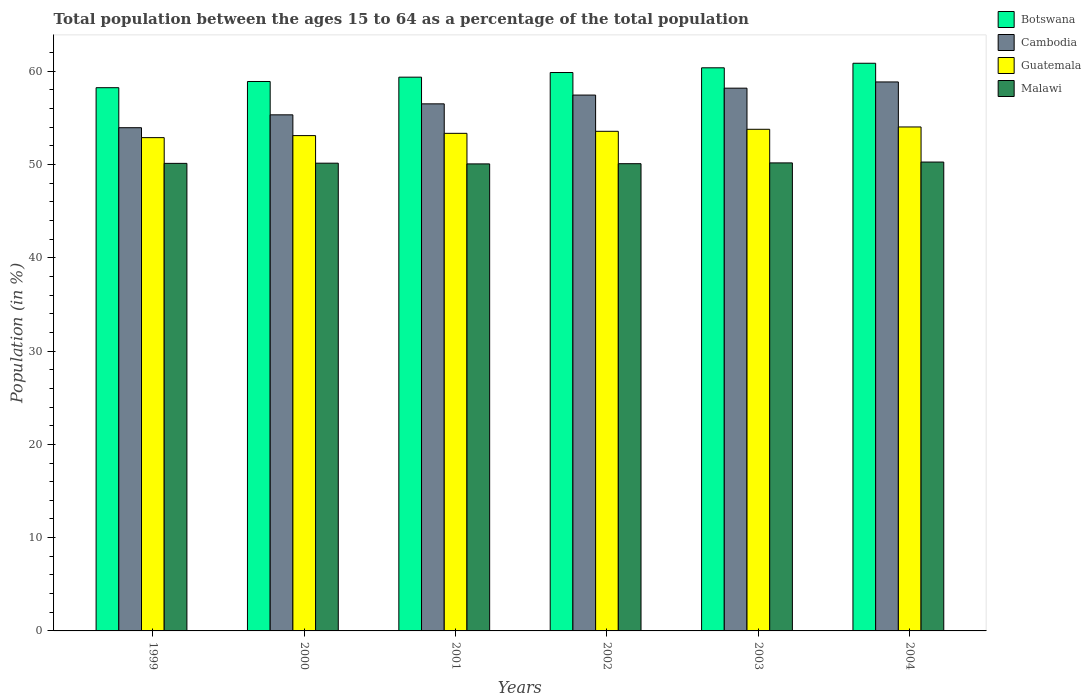How many different coloured bars are there?
Your answer should be compact. 4. How many groups of bars are there?
Your answer should be compact. 6. Are the number of bars on each tick of the X-axis equal?
Your answer should be very brief. Yes. How many bars are there on the 3rd tick from the left?
Your response must be concise. 4. What is the label of the 5th group of bars from the left?
Offer a terse response. 2003. In how many cases, is the number of bars for a given year not equal to the number of legend labels?
Offer a terse response. 0. What is the percentage of the population ages 15 to 64 in Malawi in 2001?
Provide a short and direct response. 50.06. Across all years, what is the maximum percentage of the population ages 15 to 64 in Malawi?
Offer a terse response. 50.26. Across all years, what is the minimum percentage of the population ages 15 to 64 in Malawi?
Make the answer very short. 50.06. In which year was the percentage of the population ages 15 to 64 in Cambodia maximum?
Provide a succinct answer. 2004. In which year was the percentage of the population ages 15 to 64 in Cambodia minimum?
Offer a very short reply. 1999. What is the total percentage of the population ages 15 to 64 in Botswana in the graph?
Your answer should be compact. 357.57. What is the difference between the percentage of the population ages 15 to 64 in Malawi in 1999 and that in 2004?
Provide a succinct answer. -0.14. What is the difference between the percentage of the population ages 15 to 64 in Guatemala in 2001 and the percentage of the population ages 15 to 64 in Cambodia in 2002?
Offer a very short reply. -4.1. What is the average percentage of the population ages 15 to 64 in Cambodia per year?
Ensure brevity in your answer.  56.71. In the year 2002, what is the difference between the percentage of the population ages 15 to 64 in Malawi and percentage of the population ages 15 to 64 in Botswana?
Offer a terse response. -9.77. What is the ratio of the percentage of the population ages 15 to 64 in Guatemala in 1999 to that in 2003?
Ensure brevity in your answer.  0.98. Is the percentage of the population ages 15 to 64 in Botswana in 2000 less than that in 2001?
Ensure brevity in your answer.  Yes. What is the difference between the highest and the second highest percentage of the population ages 15 to 64 in Malawi?
Offer a very short reply. 0.09. What is the difference between the highest and the lowest percentage of the population ages 15 to 64 in Malawi?
Make the answer very short. 0.2. In how many years, is the percentage of the population ages 15 to 64 in Malawi greater than the average percentage of the population ages 15 to 64 in Malawi taken over all years?
Give a very brief answer. 3. What does the 1st bar from the left in 2003 represents?
Offer a very short reply. Botswana. What does the 3rd bar from the right in 2001 represents?
Make the answer very short. Cambodia. Are all the bars in the graph horizontal?
Your answer should be compact. No. What is the difference between two consecutive major ticks on the Y-axis?
Offer a terse response. 10. Does the graph contain any zero values?
Your answer should be compact. No. Does the graph contain grids?
Provide a short and direct response. No. Where does the legend appear in the graph?
Keep it short and to the point. Top right. What is the title of the graph?
Your answer should be very brief. Total population between the ages 15 to 64 as a percentage of the total population. What is the Population (in %) in Botswana in 1999?
Ensure brevity in your answer.  58.23. What is the Population (in %) in Cambodia in 1999?
Your answer should be very brief. 53.94. What is the Population (in %) in Guatemala in 1999?
Ensure brevity in your answer.  52.88. What is the Population (in %) in Malawi in 1999?
Your answer should be compact. 50.12. What is the Population (in %) in Botswana in 2000?
Keep it short and to the point. 58.9. What is the Population (in %) of Cambodia in 2000?
Make the answer very short. 55.32. What is the Population (in %) of Guatemala in 2000?
Offer a very short reply. 53.1. What is the Population (in %) in Malawi in 2000?
Your answer should be very brief. 50.14. What is the Population (in %) in Botswana in 2001?
Ensure brevity in your answer.  59.36. What is the Population (in %) of Cambodia in 2001?
Keep it short and to the point. 56.5. What is the Population (in %) in Guatemala in 2001?
Make the answer very short. 53.34. What is the Population (in %) in Malawi in 2001?
Keep it short and to the point. 50.06. What is the Population (in %) in Botswana in 2002?
Make the answer very short. 59.86. What is the Population (in %) in Cambodia in 2002?
Your answer should be compact. 57.44. What is the Population (in %) of Guatemala in 2002?
Provide a short and direct response. 53.56. What is the Population (in %) in Malawi in 2002?
Make the answer very short. 50.09. What is the Population (in %) of Botswana in 2003?
Ensure brevity in your answer.  60.37. What is the Population (in %) in Cambodia in 2003?
Your answer should be compact. 58.18. What is the Population (in %) in Guatemala in 2003?
Your response must be concise. 53.77. What is the Population (in %) in Malawi in 2003?
Provide a succinct answer. 50.17. What is the Population (in %) of Botswana in 2004?
Your response must be concise. 60.85. What is the Population (in %) in Cambodia in 2004?
Ensure brevity in your answer.  58.85. What is the Population (in %) of Guatemala in 2004?
Make the answer very short. 54.02. What is the Population (in %) of Malawi in 2004?
Your response must be concise. 50.26. Across all years, what is the maximum Population (in %) of Botswana?
Keep it short and to the point. 60.85. Across all years, what is the maximum Population (in %) in Cambodia?
Your response must be concise. 58.85. Across all years, what is the maximum Population (in %) of Guatemala?
Your response must be concise. 54.02. Across all years, what is the maximum Population (in %) of Malawi?
Your answer should be very brief. 50.26. Across all years, what is the minimum Population (in %) in Botswana?
Ensure brevity in your answer.  58.23. Across all years, what is the minimum Population (in %) in Cambodia?
Offer a very short reply. 53.94. Across all years, what is the minimum Population (in %) of Guatemala?
Your response must be concise. 52.88. Across all years, what is the minimum Population (in %) in Malawi?
Make the answer very short. 50.06. What is the total Population (in %) in Botswana in the graph?
Your answer should be very brief. 357.57. What is the total Population (in %) in Cambodia in the graph?
Your answer should be very brief. 340.24. What is the total Population (in %) of Guatemala in the graph?
Provide a short and direct response. 320.67. What is the total Population (in %) of Malawi in the graph?
Provide a succinct answer. 300.84. What is the difference between the Population (in %) of Botswana in 1999 and that in 2000?
Your response must be concise. -0.66. What is the difference between the Population (in %) in Cambodia in 1999 and that in 2000?
Make the answer very short. -1.38. What is the difference between the Population (in %) in Guatemala in 1999 and that in 2000?
Keep it short and to the point. -0.22. What is the difference between the Population (in %) of Malawi in 1999 and that in 2000?
Your answer should be very brief. -0.02. What is the difference between the Population (in %) of Botswana in 1999 and that in 2001?
Your answer should be very brief. -1.13. What is the difference between the Population (in %) in Cambodia in 1999 and that in 2001?
Your answer should be compact. -2.56. What is the difference between the Population (in %) in Guatemala in 1999 and that in 2001?
Your answer should be very brief. -0.46. What is the difference between the Population (in %) of Malawi in 1999 and that in 2001?
Keep it short and to the point. 0.06. What is the difference between the Population (in %) of Botswana in 1999 and that in 2002?
Your response must be concise. -1.63. What is the difference between the Population (in %) of Cambodia in 1999 and that in 2002?
Your response must be concise. -3.5. What is the difference between the Population (in %) in Guatemala in 1999 and that in 2002?
Give a very brief answer. -0.68. What is the difference between the Population (in %) in Malawi in 1999 and that in 2002?
Provide a succinct answer. 0.03. What is the difference between the Population (in %) of Botswana in 1999 and that in 2003?
Your response must be concise. -2.13. What is the difference between the Population (in %) of Cambodia in 1999 and that in 2003?
Give a very brief answer. -4.24. What is the difference between the Population (in %) in Guatemala in 1999 and that in 2003?
Make the answer very short. -0.89. What is the difference between the Population (in %) of Malawi in 1999 and that in 2003?
Your answer should be very brief. -0.05. What is the difference between the Population (in %) in Botswana in 1999 and that in 2004?
Provide a succinct answer. -2.62. What is the difference between the Population (in %) in Cambodia in 1999 and that in 2004?
Your answer should be very brief. -4.91. What is the difference between the Population (in %) in Guatemala in 1999 and that in 2004?
Provide a short and direct response. -1.14. What is the difference between the Population (in %) in Malawi in 1999 and that in 2004?
Ensure brevity in your answer.  -0.14. What is the difference between the Population (in %) in Botswana in 2000 and that in 2001?
Your answer should be compact. -0.46. What is the difference between the Population (in %) of Cambodia in 2000 and that in 2001?
Offer a very short reply. -1.18. What is the difference between the Population (in %) in Guatemala in 2000 and that in 2001?
Ensure brevity in your answer.  -0.24. What is the difference between the Population (in %) in Malawi in 2000 and that in 2001?
Your response must be concise. 0.08. What is the difference between the Population (in %) in Botswana in 2000 and that in 2002?
Offer a very short reply. -0.96. What is the difference between the Population (in %) of Cambodia in 2000 and that in 2002?
Provide a succinct answer. -2.12. What is the difference between the Population (in %) of Guatemala in 2000 and that in 2002?
Your answer should be compact. -0.46. What is the difference between the Population (in %) of Malawi in 2000 and that in 2002?
Keep it short and to the point. 0.06. What is the difference between the Population (in %) in Botswana in 2000 and that in 2003?
Your answer should be compact. -1.47. What is the difference between the Population (in %) in Cambodia in 2000 and that in 2003?
Offer a very short reply. -2.86. What is the difference between the Population (in %) in Guatemala in 2000 and that in 2003?
Your answer should be very brief. -0.68. What is the difference between the Population (in %) of Malawi in 2000 and that in 2003?
Provide a succinct answer. -0.03. What is the difference between the Population (in %) in Botswana in 2000 and that in 2004?
Keep it short and to the point. -1.95. What is the difference between the Population (in %) of Cambodia in 2000 and that in 2004?
Ensure brevity in your answer.  -3.53. What is the difference between the Population (in %) in Guatemala in 2000 and that in 2004?
Your answer should be very brief. -0.93. What is the difference between the Population (in %) of Malawi in 2000 and that in 2004?
Offer a very short reply. -0.12. What is the difference between the Population (in %) of Botswana in 2001 and that in 2002?
Provide a short and direct response. -0.5. What is the difference between the Population (in %) in Cambodia in 2001 and that in 2002?
Your answer should be very brief. -0.94. What is the difference between the Population (in %) of Guatemala in 2001 and that in 2002?
Your answer should be very brief. -0.22. What is the difference between the Population (in %) of Malawi in 2001 and that in 2002?
Your answer should be very brief. -0.02. What is the difference between the Population (in %) of Botswana in 2001 and that in 2003?
Keep it short and to the point. -1. What is the difference between the Population (in %) in Cambodia in 2001 and that in 2003?
Keep it short and to the point. -1.68. What is the difference between the Population (in %) of Guatemala in 2001 and that in 2003?
Keep it short and to the point. -0.43. What is the difference between the Population (in %) of Malawi in 2001 and that in 2003?
Your answer should be compact. -0.11. What is the difference between the Population (in %) in Botswana in 2001 and that in 2004?
Give a very brief answer. -1.49. What is the difference between the Population (in %) in Cambodia in 2001 and that in 2004?
Keep it short and to the point. -2.35. What is the difference between the Population (in %) of Guatemala in 2001 and that in 2004?
Provide a succinct answer. -0.68. What is the difference between the Population (in %) in Malawi in 2001 and that in 2004?
Make the answer very short. -0.2. What is the difference between the Population (in %) in Botswana in 2002 and that in 2003?
Provide a short and direct response. -0.51. What is the difference between the Population (in %) of Cambodia in 2002 and that in 2003?
Provide a succinct answer. -0.74. What is the difference between the Population (in %) in Guatemala in 2002 and that in 2003?
Provide a short and direct response. -0.22. What is the difference between the Population (in %) of Malawi in 2002 and that in 2003?
Make the answer very short. -0.08. What is the difference between the Population (in %) in Botswana in 2002 and that in 2004?
Make the answer very short. -0.99. What is the difference between the Population (in %) of Cambodia in 2002 and that in 2004?
Provide a short and direct response. -1.41. What is the difference between the Population (in %) of Guatemala in 2002 and that in 2004?
Make the answer very short. -0.47. What is the difference between the Population (in %) in Malawi in 2002 and that in 2004?
Give a very brief answer. -0.18. What is the difference between the Population (in %) of Botswana in 2003 and that in 2004?
Provide a short and direct response. -0.49. What is the difference between the Population (in %) in Cambodia in 2003 and that in 2004?
Keep it short and to the point. -0.67. What is the difference between the Population (in %) in Guatemala in 2003 and that in 2004?
Ensure brevity in your answer.  -0.25. What is the difference between the Population (in %) of Malawi in 2003 and that in 2004?
Ensure brevity in your answer.  -0.09. What is the difference between the Population (in %) in Botswana in 1999 and the Population (in %) in Cambodia in 2000?
Make the answer very short. 2.91. What is the difference between the Population (in %) in Botswana in 1999 and the Population (in %) in Guatemala in 2000?
Give a very brief answer. 5.14. What is the difference between the Population (in %) of Botswana in 1999 and the Population (in %) of Malawi in 2000?
Offer a terse response. 8.09. What is the difference between the Population (in %) of Cambodia in 1999 and the Population (in %) of Guatemala in 2000?
Give a very brief answer. 0.85. What is the difference between the Population (in %) of Cambodia in 1999 and the Population (in %) of Malawi in 2000?
Your answer should be compact. 3.8. What is the difference between the Population (in %) in Guatemala in 1999 and the Population (in %) in Malawi in 2000?
Your answer should be very brief. 2.74. What is the difference between the Population (in %) in Botswana in 1999 and the Population (in %) in Cambodia in 2001?
Offer a terse response. 1.73. What is the difference between the Population (in %) in Botswana in 1999 and the Population (in %) in Guatemala in 2001?
Offer a terse response. 4.89. What is the difference between the Population (in %) of Botswana in 1999 and the Population (in %) of Malawi in 2001?
Your answer should be compact. 8.17. What is the difference between the Population (in %) in Cambodia in 1999 and the Population (in %) in Guatemala in 2001?
Provide a succinct answer. 0.6. What is the difference between the Population (in %) of Cambodia in 1999 and the Population (in %) of Malawi in 2001?
Your answer should be compact. 3.88. What is the difference between the Population (in %) of Guatemala in 1999 and the Population (in %) of Malawi in 2001?
Make the answer very short. 2.82. What is the difference between the Population (in %) of Botswana in 1999 and the Population (in %) of Cambodia in 2002?
Offer a very short reply. 0.79. What is the difference between the Population (in %) in Botswana in 1999 and the Population (in %) in Guatemala in 2002?
Provide a succinct answer. 4.67. What is the difference between the Population (in %) of Botswana in 1999 and the Population (in %) of Malawi in 2002?
Give a very brief answer. 8.15. What is the difference between the Population (in %) of Cambodia in 1999 and the Population (in %) of Guatemala in 2002?
Your answer should be very brief. 0.39. What is the difference between the Population (in %) of Cambodia in 1999 and the Population (in %) of Malawi in 2002?
Provide a short and direct response. 3.86. What is the difference between the Population (in %) in Guatemala in 1999 and the Population (in %) in Malawi in 2002?
Give a very brief answer. 2.79. What is the difference between the Population (in %) of Botswana in 1999 and the Population (in %) of Cambodia in 2003?
Ensure brevity in your answer.  0.05. What is the difference between the Population (in %) of Botswana in 1999 and the Population (in %) of Guatemala in 2003?
Offer a very short reply. 4.46. What is the difference between the Population (in %) of Botswana in 1999 and the Population (in %) of Malawi in 2003?
Provide a short and direct response. 8.06. What is the difference between the Population (in %) of Cambodia in 1999 and the Population (in %) of Guatemala in 2003?
Your answer should be compact. 0.17. What is the difference between the Population (in %) of Cambodia in 1999 and the Population (in %) of Malawi in 2003?
Ensure brevity in your answer.  3.77. What is the difference between the Population (in %) in Guatemala in 1999 and the Population (in %) in Malawi in 2003?
Offer a terse response. 2.71. What is the difference between the Population (in %) in Botswana in 1999 and the Population (in %) in Cambodia in 2004?
Your answer should be compact. -0.62. What is the difference between the Population (in %) in Botswana in 1999 and the Population (in %) in Guatemala in 2004?
Your response must be concise. 4.21. What is the difference between the Population (in %) of Botswana in 1999 and the Population (in %) of Malawi in 2004?
Give a very brief answer. 7.97. What is the difference between the Population (in %) in Cambodia in 1999 and the Population (in %) in Guatemala in 2004?
Offer a very short reply. -0.08. What is the difference between the Population (in %) of Cambodia in 1999 and the Population (in %) of Malawi in 2004?
Offer a very short reply. 3.68. What is the difference between the Population (in %) in Guatemala in 1999 and the Population (in %) in Malawi in 2004?
Offer a terse response. 2.62. What is the difference between the Population (in %) of Botswana in 2000 and the Population (in %) of Cambodia in 2001?
Offer a terse response. 2.4. What is the difference between the Population (in %) in Botswana in 2000 and the Population (in %) in Guatemala in 2001?
Keep it short and to the point. 5.56. What is the difference between the Population (in %) of Botswana in 2000 and the Population (in %) of Malawi in 2001?
Provide a succinct answer. 8.83. What is the difference between the Population (in %) in Cambodia in 2000 and the Population (in %) in Guatemala in 2001?
Your answer should be very brief. 1.98. What is the difference between the Population (in %) in Cambodia in 2000 and the Population (in %) in Malawi in 2001?
Your response must be concise. 5.26. What is the difference between the Population (in %) in Guatemala in 2000 and the Population (in %) in Malawi in 2001?
Give a very brief answer. 3.03. What is the difference between the Population (in %) of Botswana in 2000 and the Population (in %) of Cambodia in 2002?
Give a very brief answer. 1.46. What is the difference between the Population (in %) of Botswana in 2000 and the Population (in %) of Guatemala in 2002?
Make the answer very short. 5.34. What is the difference between the Population (in %) of Botswana in 2000 and the Population (in %) of Malawi in 2002?
Offer a terse response. 8.81. What is the difference between the Population (in %) of Cambodia in 2000 and the Population (in %) of Guatemala in 2002?
Offer a terse response. 1.76. What is the difference between the Population (in %) of Cambodia in 2000 and the Population (in %) of Malawi in 2002?
Offer a terse response. 5.24. What is the difference between the Population (in %) of Guatemala in 2000 and the Population (in %) of Malawi in 2002?
Provide a short and direct response. 3.01. What is the difference between the Population (in %) in Botswana in 2000 and the Population (in %) in Cambodia in 2003?
Your answer should be compact. 0.72. What is the difference between the Population (in %) in Botswana in 2000 and the Population (in %) in Guatemala in 2003?
Your response must be concise. 5.12. What is the difference between the Population (in %) in Botswana in 2000 and the Population (in %) in Malawi in 2003?
Keep it short and to the point. 8.73. What is the difference between the Population (in %) of Cambodia in 2000 and the Population (in %) of Guatemala in 2003?
Keep it short and to the point. 1.55. What is the difference between the Population (in %) of Cambodia in 2000 and the Population (in %) of Malawi in 2003?
Provide a short and direct response. 5.15. What is the difference between the Population (in %) in Guatemala in 2000 and the Population (in %) in Malawi in 2003?
Give a very brief answer. 2.93. What is the difference between the Population (in %) in Botswana in 2000 and the Population (in %) in Cambodia in 2004?
Your answer should be very brief. 0.05. What is the difference between the Population (in %) of Botswana in 2000 and the Population (in %) of Guatemala in 2004?
Provide a succinct answer. 4.87. What is the difference between the Population (in %) in Botswana in 2000 and the Population (in %) in Malawi in 2004?
Ensure brevity in your answer.  8.64. What is the difference between the Population (in %) in Cambodia in 2000 and the Population (in %) in Guatemala in 2004?
Ensure brevity in your answer.  1.3. What is the difference between the Population (in %) of Cambodia in 2000 and the Population (in %) of Malawi in 2004?
Give a very brief answer. 5.06. What is the difference between the Population (in %) in Guatemala in 2000 and the Population (in %) in Malawi in 2004?
Your response must be concise. 2.84. What is the difference between the Population (in %) in Botswana in 2001 and the Population (in %) in Cambodia in 2002?
Keep it short and to the point. 1.92. What is the difference between the Population (in %) in Botswana in 2001 and the Population (in %) in Guatemala in 2002?
Your answer should be very brief. 5.8. What is the difference between the Population (in %) in Botswana in 2001 and the Population (in %) in Malawi in 2002?
Give a very brief answer. 9.28. What is the difference between the Population (in %) in Cambodia in 2001 and the Population (in %) in Guatemala in 2002?
Your answer should be compact. 2.94. What is the difference between the Population (in %) in Cambodia in 2001 and the Population (in %) in Malawi in 2002?
Give a very brief answer. 6.42. What is the difference between the Population (in %) of Guatemala in 2001 and the Population (in %) of Malawi in 2002?
Make the answer very short. 3.25. What is the difference between the Population (in %) in Botswana in 2001 and the Population (in %) in Cambodia in 2003?
Your response must be concise. 1.18. What is the difference between the Population (in %) in Botswana in 2001 and the Population (in %) in Guatemala in 2003?
Provide a succinct answer. 5.59. What is the difference between the Population (in %) of Botswana in 2001 and the Population (in %) of Malawi in 2003?
Your answer should be compact. 9.19. What is the difference between the Population (in %) of Cambodia in 2001 and the Population (in %) of Guatemala in 2003?
Keep it short and to the point. 2.73. What is the difference between the Population (in %) in Cambodia in 2001 and the Population (in %) in Malawi in 2003?
Keep it short and to the point. 6.33. What is the difference between the Population (in %) of Guatemala in 2001 and the Population (in %) of Malawi in 2003?
Provide a short and direct response. 3.17. What is the difference between the Population (in %) of Botswana in 2001 and the Population (in %) of Cambodia in 2004?
Give a very brief answer. 0.51. What is the difference between the Population (in %) in Botswana in 2001 and the Population (in %) in Guatemala in 2004?
Your answer should be very brief. 5.34. What is the difference between the Population (in %) in Botswana in 2001 and the Population (in %) in Malawi in 2004?
Your response must be concise. 9.1. What is the difference between the Population (in %) of Cambodia in 2001 and the Population (in %) of Guatemala in 2004?
Your answer should be compact. 2.48. What is the difference between the Population (in %) in Cambodia in 2001 and the Population (in %) in Malawi in 2004?
Your answer should be compact. 6.24. What is the difference between the Population (in %) in Guatemala in 2001 and the Population (in %) in Malawi in 2004?
Your answer should be very brief. 3.08. What is the difference between the Population (in %) of Botswana in 2002 and the Population (in %) of Cambodia in 2003?
Provide a succinct answer. 1.68. What is the difference between the Population (in %) of Botswana in 2002 and the Population (in %) of Guatemala in 2003?
Your answer should be compact. 6.08. What is the difference between the Population (in %) in Botswana in 2002 and the Population (in %) in Malawi in 2003?
Provide a succinct answer. 9.69. What is the difference between the Population (in %) of Cambodia in 2002 and the Population (in %) of Guatemala in 2003?
Your response must be concise. 3.67. What is the difference between the Population (in %) in Cambodia in 2002 and the Population (in %) in Malawi in 2003?
Your answer should be very brief. 7.27. What is the difference between the Population (in %) of Guatemala in 2002 and the Population (in %) of Malawi in 2003?
Your response must be concise. 3.39. What is the difference between the Population (in %) of Botswana in 2002 and the Population (in %) of Cambodia in 2004?
Keep it short and to the point. 1.01. What is the difference between the Population (in %) of Botswana in 2002 and the Population (in %) of Guatemala in 2004?
Provide a succinct answer. 5.83. What is the difference between the Population (in %) in Botswana in 2002 and the Population (in %) in Malawi in 2004?
Provide a succinct answer. 9.6. What is the difference between the Population (in %) of Cambodia in 2002 and the Population (in %) of Guatemala in 2004?
Offer a very short reply. 3.42. What is the difference between the Population (in %) in Cambodia in 2002 and the Population (in %) in Malawi in 2004?
Ensure brevity in your answer.  7.18. What is the difference between the Population (in %) in Guatemala in 2002 and the Population (in %) in Malawi in 2004?
Make the answer very short. 3.3. What is the difference between the Population (in %) in Botswana in 2003 and the Population (in %) in Cambodia in 2004?
Keep it short and to the point. 1.52. What is the difference between the Population (in %) in Botswana in 2003 and the Population (in %) in Guatemala in 2004?
Ensure brevity in your answer.  6.34. What is the difference between the Population (in %) in Botswana in 2003 and the Population (in %) in Malawi in 2004?
Offer a very short reply. 10.1. What is the difference between the Population (in %) of Cambodia in 2003 and the Population (in %) of Guatemala in 2004?
Provide a short and direct response. 4.16. What is the difference between the Population (in %) of Cambodia in 2003 and the Population (in %) of Malawi in 2004?
Your answer should be compact. 7.92. What is the difference between the Population (in %) of Guatemala in 2003 and the Population (in %) of Malawi in 2004?
Keep it short and to the point. 3.51. What is the average Population (in %) of Botswana per year?
Keep it short and to the point. 59.59. What is the average Population (in %) in Cambodia per year?
Ensure brevity in your answer.  56.71. What is the average Population (in %) of Guatemala per year?
Give a very brief answer. 53.45. What is the average Population (in %) of Malawi per year?
Your answer should be very brief. 50.14. In the year 1999, what is the difference between the Population (in %) in Botswana and Population (in %) in Cambodia?
Your response must be concise. 4.29. In the year 1999, what is the difference between the Population (in %) of Botswana and Population (in %) of Guatemala?
Offer a terse response. 5.35. In the year 1999, what is the difference between the Population (in %) in Botswana and Population (in %) in Malawi?
Ensure brevity in your answer.  8.11. In the year 1999, what is the difference between the Population (in %) in Cambodia and Population (in %) in Guatemala?
Offer a terse response. 1.06. In the year 1999, what is the difference between the Population (in %) of Cambodia and Population (in %) of Malawi?
Provide a succinct answer. 3.82. In the year 1999, what is the difference between the Population (in %) in Guatemala and Population (in %) in Malawi?
Make the answer very short. 2.76. In the year 2000, what is the difference between the Population (in %) of Botswana and Population (in %) of Cambodia?
Make the answer very short. 3.58. In the year 2000, what is the difference between the Population (in %) of Botswana and Population (in %) of Guatemala?
Give a very brief answer. 5.8. In the year 2000, what is the difference between the Population (in %) of Botswana and Population (in %) of Malawi?
Your answer should be very brief. 8.76. In the year 2000, what is the difference between the Population (in %) of Cambodia and Population (in %) of Guatemala?
Your response must be concise. 2.23. In the year 2000, what is the difference between the Population (in %) of Cambodia and Population (in %) of Malawi?
Ensure brevity in your answer.  5.18. In the year 2000, what is the difference between the Population (in %) in Guatemala and Population (in %) in Malawi?
Your answer should be very brief. 2.96. In the year 2001, what is the difference between the Population (in %) of Botswana and Population (in %) of Cambodia?
Provide a short and direct response. 2.86. In the year 2001, what is the difference between the Population (in %) in Botswana and Population (in %) in Guatemala?
Your answer should be compact. 6.02. In the year 2001, what is the difference between the Population (in %) of Botswana and Population (in %) of Malawi?
Ensure brevity in your answer.  9.3. In the year 2001, what is the difference between the Population (in %) in Cambodia and Population (in %) in Guatemala?
Give a very brief answer. 3.16. In the year 2001, what is the difference between the Population (in %) of Cambodia and Population (in %) of Malawi?
Offer a terse response. 6.44. In the year 2001, what is the difference between the Population (in %) in Guatemala and Population (in %) in Malawi?
Make the answer very short. 3.28. In the year 2002, what is the difference between the Population (in %) in Botswana and Population (in %) in Cambodia?
Give a very brief answer. 2.42. In the year 2002, what is the difference between the Population (in %) in Botswana and Population (in %) in Guatemala?
Offer a terse response. 6.3. In the year 2002, what is the difference between the Population (in %) of Botswana and Population (in %) of Malawi?
Give a very brief answer. 9.77. In the year 2002, what is the difference between the Population (in %) in Cambodia and Population (in %) in Guatemala?
Ensure brevity in your answer.  3.88. In the year 2002, what is the difference between the Population (in %) in Cambodia and Population (in %) in Malawi?
Offer a very short reply. 7.36. In the year 2002, what is the difference between the Population (in %) in Guatemala and Population (in %) in Malawi?
Offer a very short reply. 3.47. In the year 2003, what is the difference between the Population (in %) in Botswana and Population (in %) in Cambodia?
Provide a succinct answer. 2.18. In the year 2003, what is the difference between the Population (in %) of Botswana and Population (in %) of Guatemala?
Offer a terse response. 6.59. In the year 2003, what is the difference between the Population (in %) in Botswana and Population (in %) in Malawi?
Offer a very short reply. 10.2. In the year 2003, what is the difference between the Population (in %) in Cambodia and Population (in %) in Guatemala?
Your answer should be very brief. 4.41. In the year 2003, what is the difference between the Population (in %) in Cambodia and Population (in %) in Malawi?
Provide a succinct answer. 8.01. In the year 2003, what is the difference between the Population (in %) of Guatemala and Population (in %) of Malawi?
Make the answer very short. 3.6. In the year 2004, what is the difference between the Population (in %) in Botswana and Population (in %) in Cambodia?
Your response must be concise. 2. In the year 2004, what is the difference between the Population (in %) in Botswana and Population (in %) in Guatemala?
Provide a succinct answer. 6.83. In the year 2004, what is the difference between the Population (in %) in Botswana and Population (in %) in Malawi?
Provide a succinct answer. 10.59. In the year 2004, what is the difference between the Population (in %) in Cambodia and Population (in %) in Guatemala?
Your answer should be very brief. 4.83. In the year 2004, what is the difference between the Population (in %) in Cambodia and Population (in %) in Malawi?
Ensure brevity in your answer.  8.59. In the year 2004, what is the difference between the Population (in %) in Guatemala and Population (in %) in Malawi?
Keep it short and to the point. 3.76. What is the ratio of the Population (in %) of Botswana in 1999 to that in 2000?
Provide a short and direct response. 0.99. What is the ratio of the Population (in %) in Cambodia in 1999 to that in 2000?
Your answer should be compact. 0.98. What is the ratio of the Population (in %) in Guatemala in 1999 to that in 2000?
Make the answer very short. 1. What is the ratio of the Population (in %) in Cambodia in 1999 to that in 2001?
Provide a succinct answer. 0.95. What is the ratio of the Population (in %) in Botswana in 1999 to that in 2002?
Give a very brief answer. 0.97. What is the ratio of the Population (in %) in Cambodia in 1999 to that in 2002?
Offer a terse response. 0.94. What is the ratio of the Population (in %) in Guatemala in 1999 to that in 2002?
Provide a short and direct response. 0.99. What is the ratio of the Population (in %) of Botswana in 1999 to that in 2003?
Your answer should be very brief. 0.96. What is the ratio of the Population (in %) in Cambodia in 1999 to that in 2003?
Keep it short and to the point. 0.93. What is the ratio of the Population (in %) of Guatemala in 1999 to that in 2003?
Give a very brief answer. 0.98. What is the ratio of the Population (in %) in Malawi in 1999 to that in 2003?
Offer a terse response. 1. What is the ratio of the Population (in %) in Botswana in 1999 to that in 2004?
Your answer should be compact. 0.96. What is the ratio of the Population (in %) of Cambodia in 1999 to that in 2004?
Your answer should be compact. 0.92. What is the ratio of the Population (in %) in Guatemala in 1999 to that in 2004?
Your answer should be compact. 0.98. What is the ratio of the Population (in %) in Botswana in 2000 to that in 2001?
Keep it short and to the point. 0.99. What is the ratio of the Population (in %) in Cambodia in 2000 to that in 2001?
Ensure brevity in your answer.  0.98. What is the ratio of the Population (in %) of Guatemala in 2000 to that in 2001?
Make the answer very short. 1. What is the ratio of the Population (in %) of Malawi in 2000 to that in 2001?
Your answer should be compact. 1. What is the ratio of the Population (in %) in Botswana in 2000 to that in 2002?
Ensure brevity in your answer.  0.98. What is the ratio of the Population (in %) in Cambodia in 2000 to that in 2002?
Give a very brief answer. 0.96. What is the ratio of the Population (in %) of Malawi in 2000 to that in 2002?
Offer a terse response. 1. What is the ratio of the Population (in %) of Botswana in 2000 to that in 2003?
Offer a terse response. 0.98. What is the ratio of the Population (in %) of Cambodia in 2000 to that in 2003?
Make the answer very short. 0.95. What is the ratio of the Population (in %) of Guatemala in 2000 to that in 2003?
Offer a very short reply. 0.99. What is the ratio of the Population (in %) in Malawi in 2000 to that in 2003?
Provide a succinct answer. 1. What is the ratio of the Population (in %) in Botswana in 2000 to that in 2004?
Your answer should be compact. 0.97. What is the ratio of the Population (in %) in Cambodia in 2000 to that in 2004?
Ensure brevity in your answer.  0.94. What is the ratio of the Population (in %) in Guatemala in 2000 to that in 2004?
Give a very brief answer. 0.98. What is the ratio of the Population (in %) in Cambodia in 2001 to that in 2002?
Keep it short and to the point. 0.98. What is the ratio of the Population (in %) of Guatemala in 2001 to that in 2002?
Provide a short and direct response. 1. What is the ratio of the Population (in %) in Malawi in 2001 to that in 2002?
Ensure brevity in your answer.  1. What is the ratio of the Population (in %) of Botswana in 2001 to that in 2003?
Your response must be concise. 0.98. What is the ratio of the Population (in %) of Cambodia in 2001 to that in 2003?
Make the answer very short. 0.97. What is the ratio of the Population (in %) of Malawi in 2001 to that in 2003?
Ensure brevity in your answer.  1. What is the ratio of the Population (in %) of Botswana in 2001 to that in 2004?
Your answer should be very brief. 0.98. What is the ratio of the Population (in %) of Cambodia in 2001 to that in 2004?
Give a very brief answer. 0.96. What is the ratio of the Population (in %) of Guatemala in 2001 to that in 2004?
Make the answer very short. 0.99. What is the ratio of the Population (in %) of Botswana in 2002 to that in 2003?
Your answer should be compact. 0.99. What is the ratio of the Population (in %) of Cambodia in 2002 to that in 2003?
Provide a succinct answer. 0.99. What is the ratio of the Population (in %) in Guatemala in 2002 to that in 2003?
Provide a short and direct response. 1. What is the ratio of the Population (in %) in Malawi in 2002 to that in 2003?
Ensure brevity in your answer.  1. What is the ratio of the Population (in %) in Botswana in 2002 to that in 2004?
Provide a succinct answer. 0.98. What is the ratio of the Population (in %) of Cambodia in 2002 to that in 2004?
Offer a terse response. 0.98. What is the ratio of the Population (in %) of Malawi in 2002 to that in 2004?
Ensure brevity in your answer.  1. What is the ratio of the Population (in %) of Botswana in 2003 to that in 2004?
Provide a succinct answer. 0.99. What is the ratio of the Population (in %) in Cambodia in 2003 to that in 2004?
Your response must be concise. 0.99. What is the difference between the highest and the second highest Population (in %) of Botswana?
Your response must be concise. 0.49. What is the difference between the highest and the second highest Population (in %) in Cambodia?
Your response must be concise. 0.67. What is the difference between the highest and the second highest Population (in %) of Guatemala?
Provide a short and direct response. 0.25. What is the difference between the highest and the second highest Population (in %) of Malawi?
Your answer should be compact. 0.09. What is the difference between the highest and the lowest Population (in %) of Botswana?
Your answer should be very brief. 2.62. What is the difference between the highest and the lowest Population (in %) of Cambodia?
Make the answer very short. 4.91. What is the difference between the highest and the lowest Population (in %) in Guatemala?
Your answer should be very brief. 1.14. What is the difference between the highest and the lowest Population (in %) of Malawi?
Give a very brief answer. 0.2. 